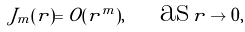<formula> <loc_0><loc_0><loc_500><loc_500>J _ { m } ( r ) = O ( r ^ { m } ) , \quad \text {as} \, r \to 0 ,</formula> 